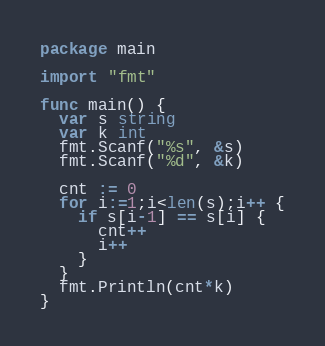<code> <loc_0><loc_0><loc_500><loc_500><_Go_>package main

import "fmt"

func main() {
  var s string
  var k int
  fmt.Scanf("%s", &s)
  fmt.Scanf("%d", &k)

  cnt := 0
  for i:=1;i<len(s);i++ {
    if s[i-1] == s[i] {
      cnt++
      i++
    }
  }
  fmt.Println(cnt*k)
}</code> 